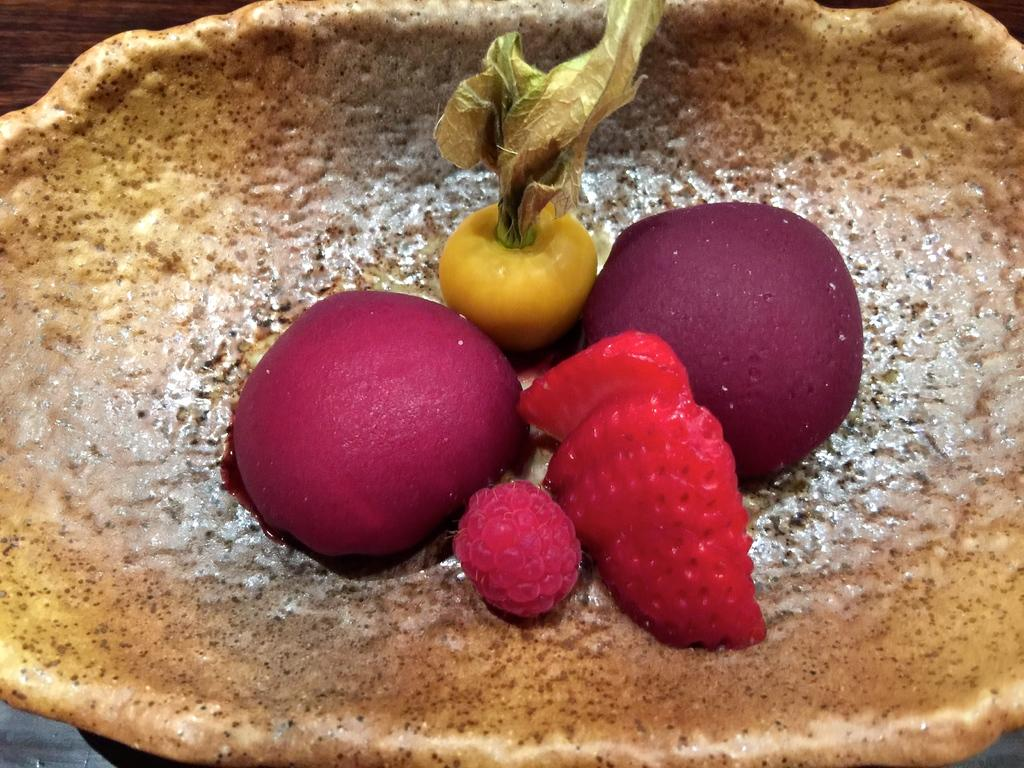What type of food items are present in the image? There are fruits in the image. What is located at the bottom of the image? There is a basket at the bottom of the image. What type of furniture is visible in the image? There is a wooden table in the image. What type of spy equipment can be seen in the image? There is no spy equipment present in the image. What type of liquid is being poured from a container in the image? There is no liquid being poured in the image; it only features fruits, a basket, and a wooden table. 